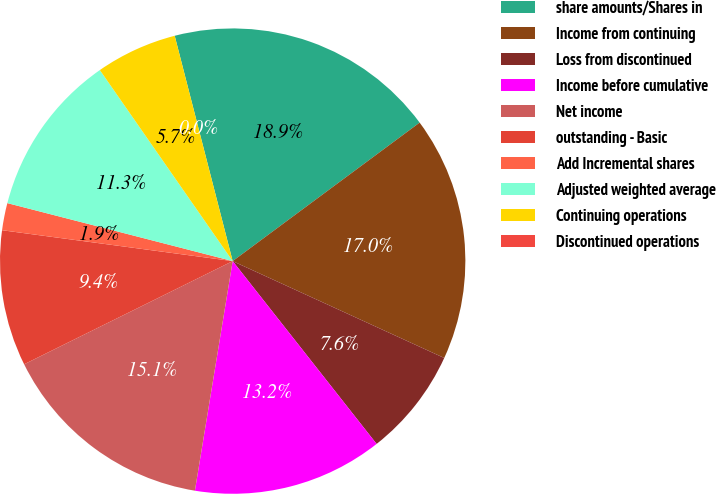<chart> <loc_0><loc_0><loc_500><loc_500><pie_chart><fcel>share amounts/Shares in<fcel>Income from continuing<fcel>Loss from discontinued<fcel>Income before cumulative<fcel>Net income<fcel>outstanding - Basic<fcel>Add Incremental shares<fcel>Adjusted weighted average<fcel>Continuing operations<fcel>Discontinued operations<nl><fcel>18.86%<fcel>16.98%<fcel>7.55%<fcel>13.21%<fcel>15.09%<fcel>9.43%<fcel>1.89%<fcel>11.32%<fcel>5.66%<fcel>0.0%<nl></chart> 